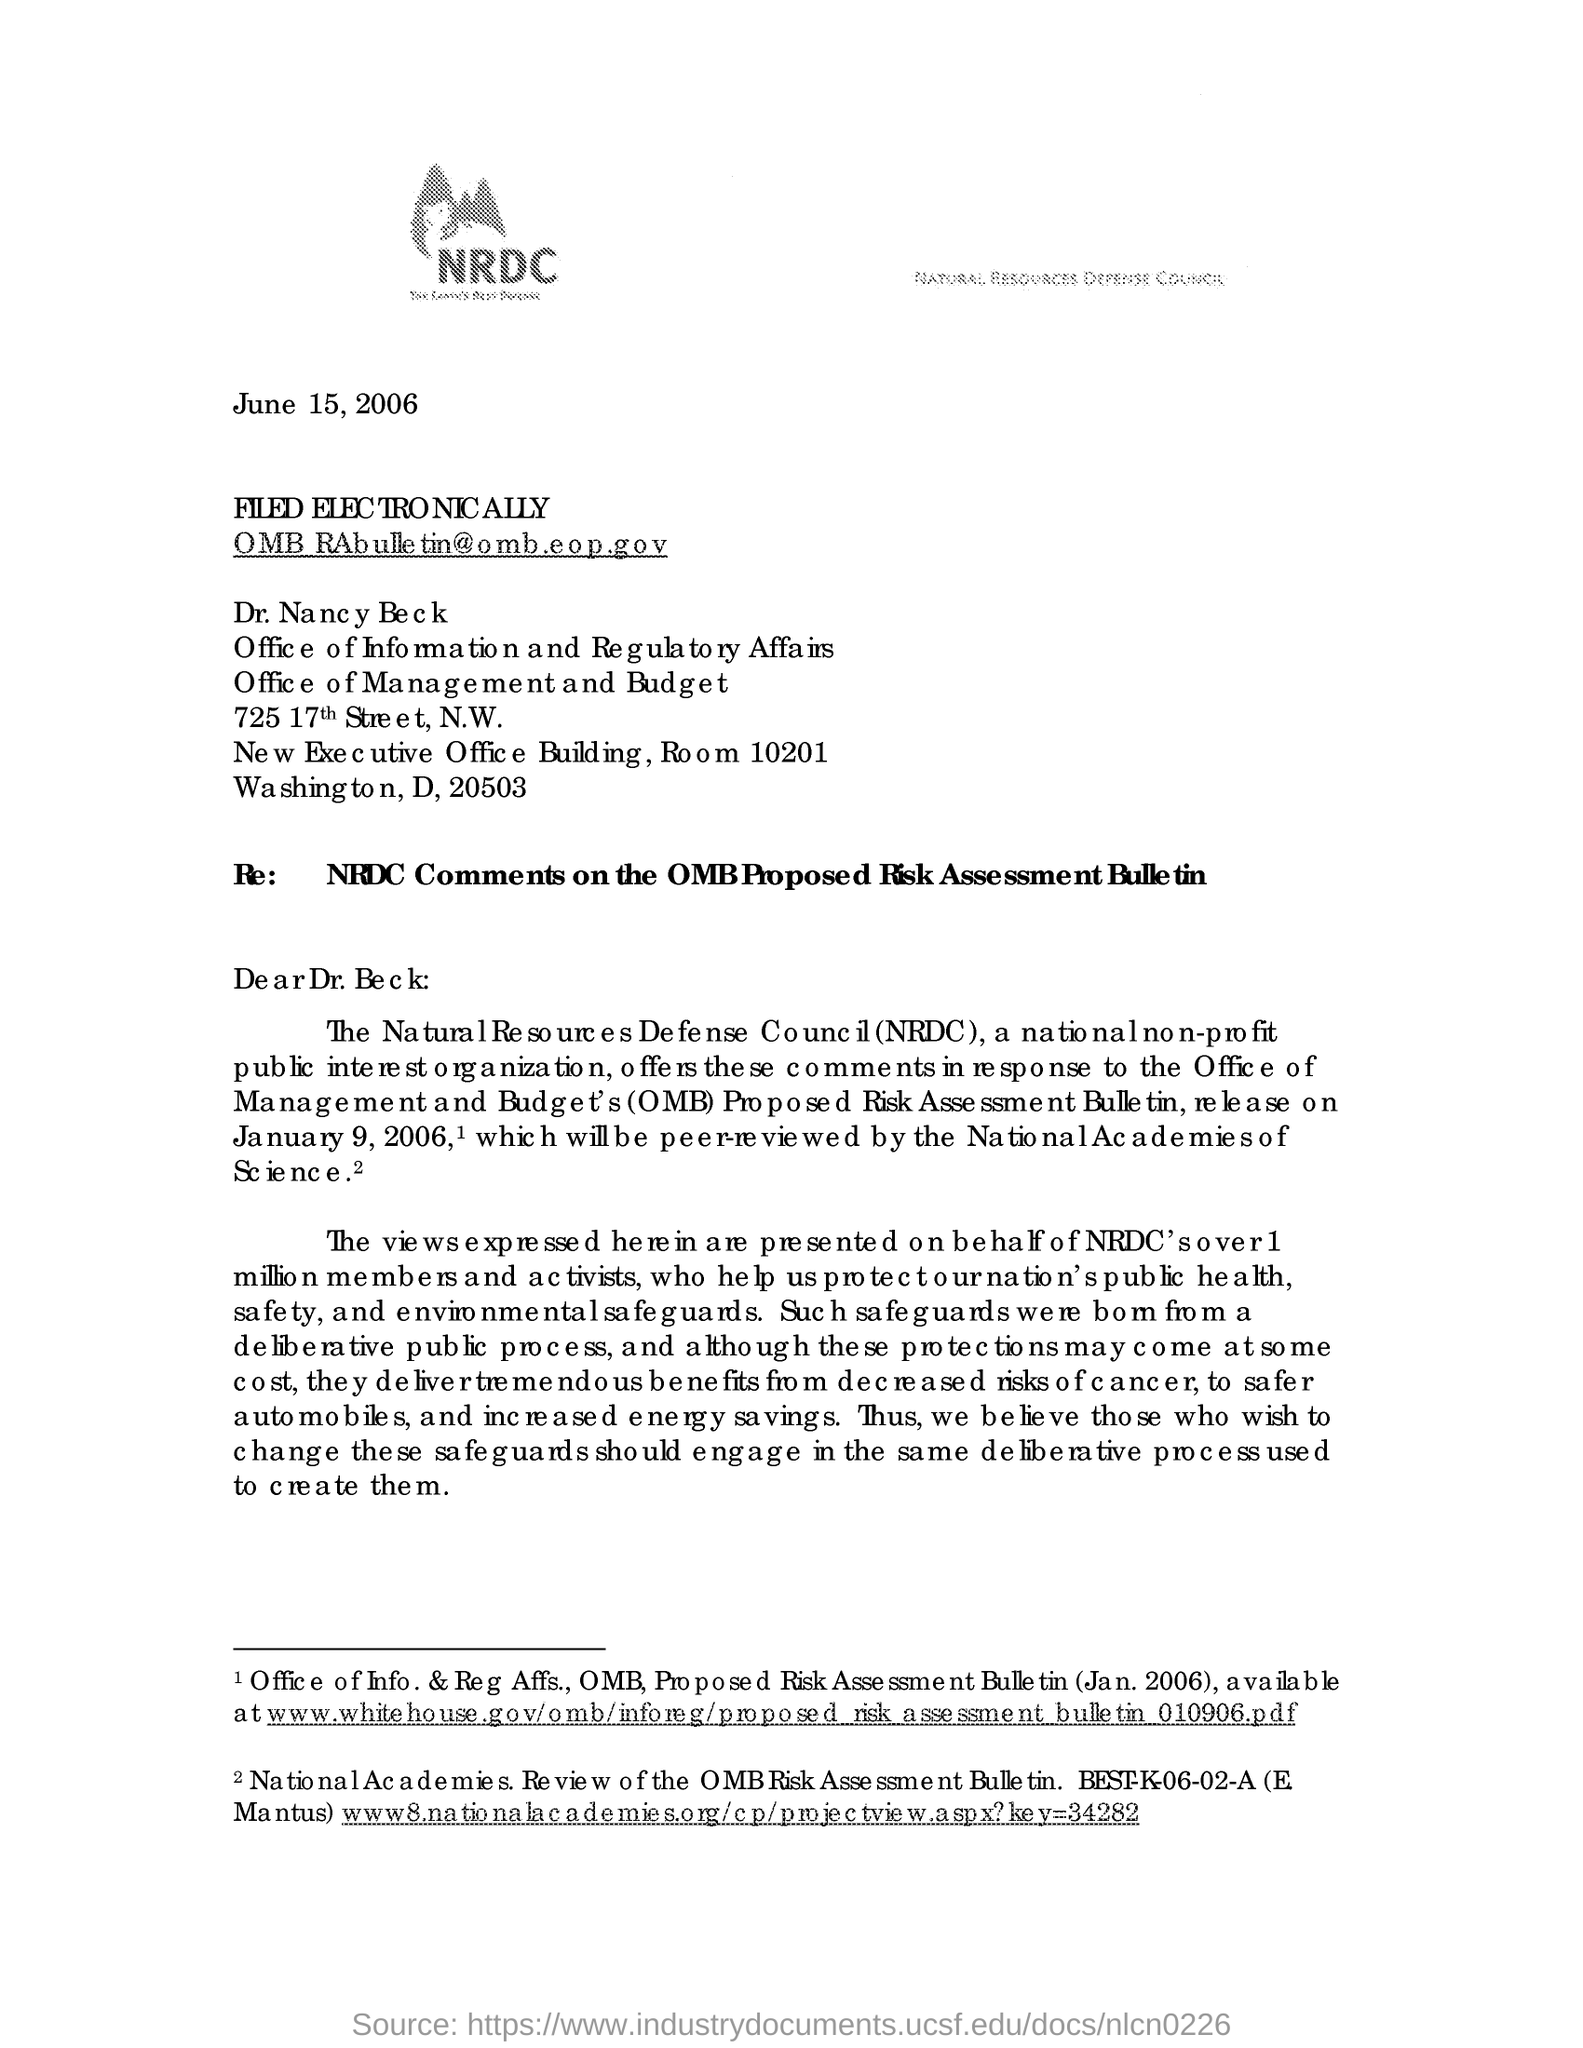Outline some significant characteristics in this image. The Natural Resources Defense Council, commonly referred to as NRDC, is an environmental organization that works to protect and preserve natural resources for future generations. The subject line of this letter is "Re: NRDC Comments on the OMB Proposed Risk Assessment Bulletin. The issued date of this document is June 15, 2006. NRDC is a national, non-profit public interest organization. The addressee of this letter is Dr. Beck. 